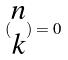Convert formula to latex. <formula><loc_0><loc_0><loc_500><loc_500>( \begin{matrix} n \\ k \end{matrix} ) = 0</formula> 